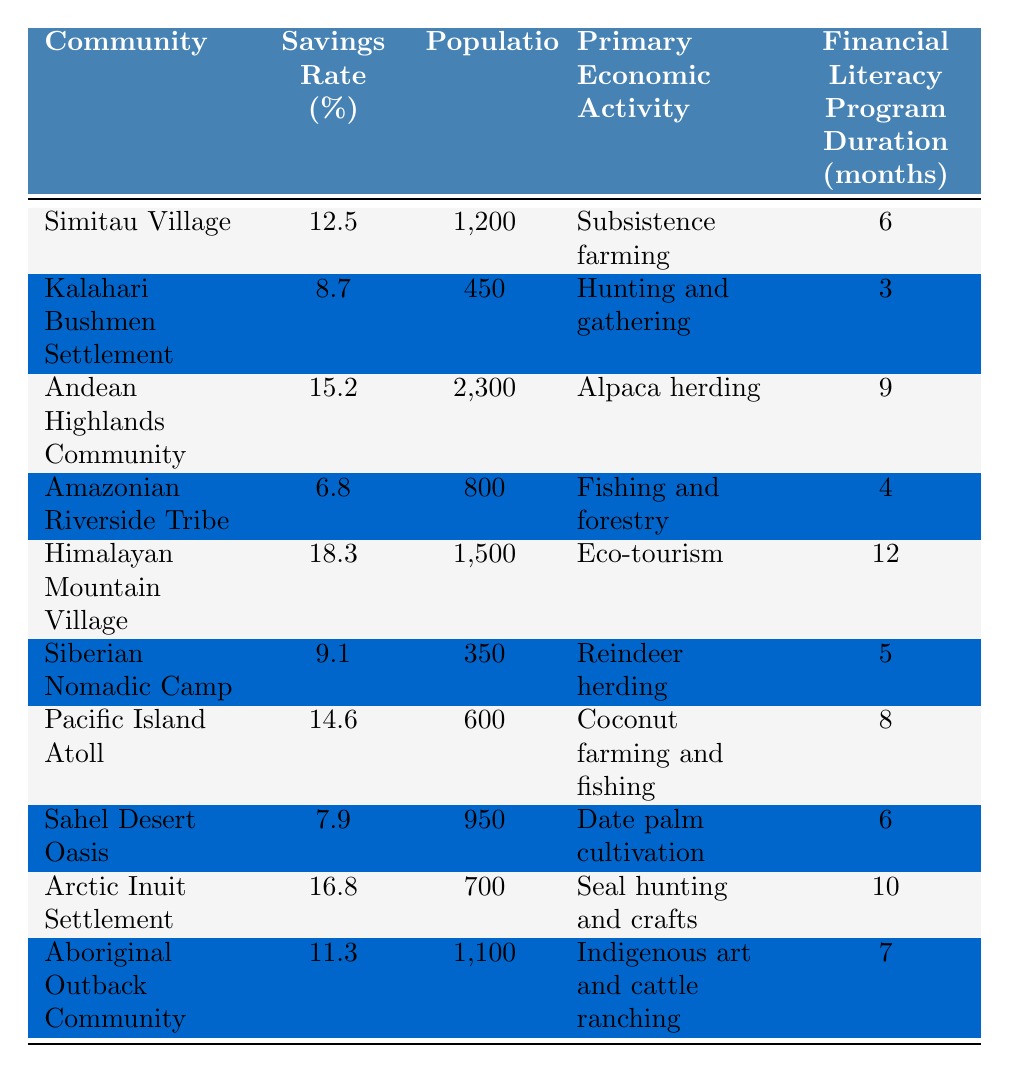What is the savings rate of the Himalayan Mountain Village? The savings rate of the Himalayan Mountain Village is explicitly given in the table as 18.3%.
Answer: 18.3% Which community has the lowest savings rate? By comparing the savings rates listed in the table, the Amazonian Riverside Tribe has the lowest savings rate at 6.8%.
Answer: 6.8% How many communities have a savings rate above 15%? The table shows the savings rates of the communities. The Andean Highlands Community, Himalayan Mountain Village, and Arctic Inuit Settlement have savings rates above 15%, totaling three communities.
Answer: 3 What is the population of the Kalahari Bushmen Settlement? The table lists the Kalahari Bushmen Settlement's population as 450.
Answer: 450 Calculate the average savings rate of all the communities. To find the average savings rate, sum all the savings rates: 12.5 + 8.7 + 15.2 + 6.8 + 18.3 + 9.1 + 14.6 + 7.9 + 16.8 + 11.3 = 119.4. Then, divide by the number of communities (10): 119.4 / 10 = 11.94%.
Answer: 11.94% Is there a community with a savings rate of exactly 10%? Reviewing the table, there is no community listed with a savings rate of exactly 10%.
Answer: No Which economic activity corresponds to the highest savings rate? The highest savings rate is 18.3%, which corresponds to the economic activity of eco-tourism in the Himalayan Mountain Village.
Answer: Eco-tourism How many months of financial literacy program does the Arctic Inuit Settlement have? The table indicates that the Arctic Inuit Settlement has a financial literacy program duration of 10 months.
Answer: 10 months Which community, with a population greater than 1000, has the highest savings rate? Among communities with populations greater than 1000, the Himalayan Mountain Village has the highest savings rate at 18.3%.
Answer: Himalayan Mountain Village What is the difference between the highest and lowest savings rates? The highest savings rate is 18.3% (Himalayan Mountain Village) and the lowest savings rate is 6.8% (Amazonian Riverside Tribe). The difference is 18.3% - 6.8% = 11.5%.
Answer: 11.5% How many communities rely on farming as their primary economic activity? The table shows that Simitau Village (subsistence farming), Pacific Island Atoll (coconut farming), and Sahel Desert Oasis (date palm cultivation) specify farming in their economic activities, totaling three communities.
Answer: 3 